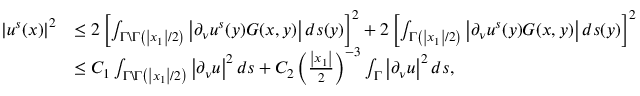<formula> <loc_0><loc_0><loc_500><loc_500>\begin{array} { r l } { \left | u ^ { s } ( x ) \right | ^ { 2 } } & { \leq 2 \left [ \int _ { \Gamma \ \Gamma \left ( \left | x _ { 1 } \right | / 2 \right ) } \left | \partial _ { \nu } u ^ { s } ( y ) G ( x , y ) \right | d s ( y ) \right ] ^ { 2 } + 2 \left [ \int _ { \Gamma \left ( \left | x _ { 1 } \right | / 2 \right ) } \left | \partial _ { \nu } u ^ { s } ( y ) G ( x , y ) \right | d s ( y ) \right ] ^ { 2 } } \\ & { \leq C _ { 1 } \int _ { \Gamma \ \Gamma \left ( \left | x _ { 1 } \right | / 2 \right ) } \left | \partial _ { \nu } u \right | ^ { 2 } d s + C _ { 2 } \left ( \frac { \left | x _ { 1 } \right | } { 2 } \right ) ^ { - 3 } \int _ { \Gamma } \left | \partial _ { \nu } u \right | ^ { 2 } d s , } \end{array}</formula> 